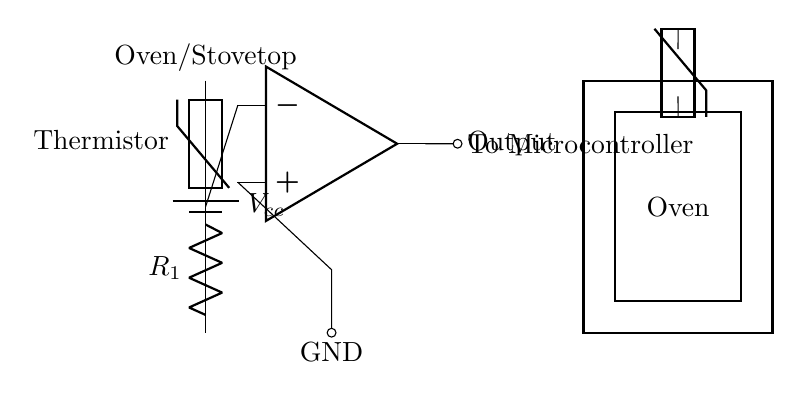What type of sensor is used in this circuit? The circuit utilizes a thermistor, which is a type of temperature sensor that changes its resistance with temperature. This is indicated by the label on the component in the diagram.
Answer: Thermistor What is connected to the output of the operational amplifier? The output of the operational amplifier is connected to the microcontroller, which is indicated by the label next to the connection line leading from the op-amp's output.
Answer: Microcontroller How many resistors are present in the circuit? There is one resistor labeled as R1 present in the circuit, shown connected between the thermistor and ground.
Answer: One Which component connects directly to ground? The operational amplifier's non-inverting input is connected directly to ground, which is depicted in the diagram as a line running to the point labeled ground.
Answer: Operational amplifier What is the function of the resistor labeled R1? The resistor R1 works with the thermistor to create a voltage divider, which allows the circuit to accurately read different temperature levels by adjusting the voltage based on the thermistor's resistance.
Answer: Voltage divider How is the thermistor connected in the circuit? The thermistor is connected in series with the resistor R1, which forms a part of the voltage divider setup for the operational amplifier to function correctly.
Answer: In series with R1 